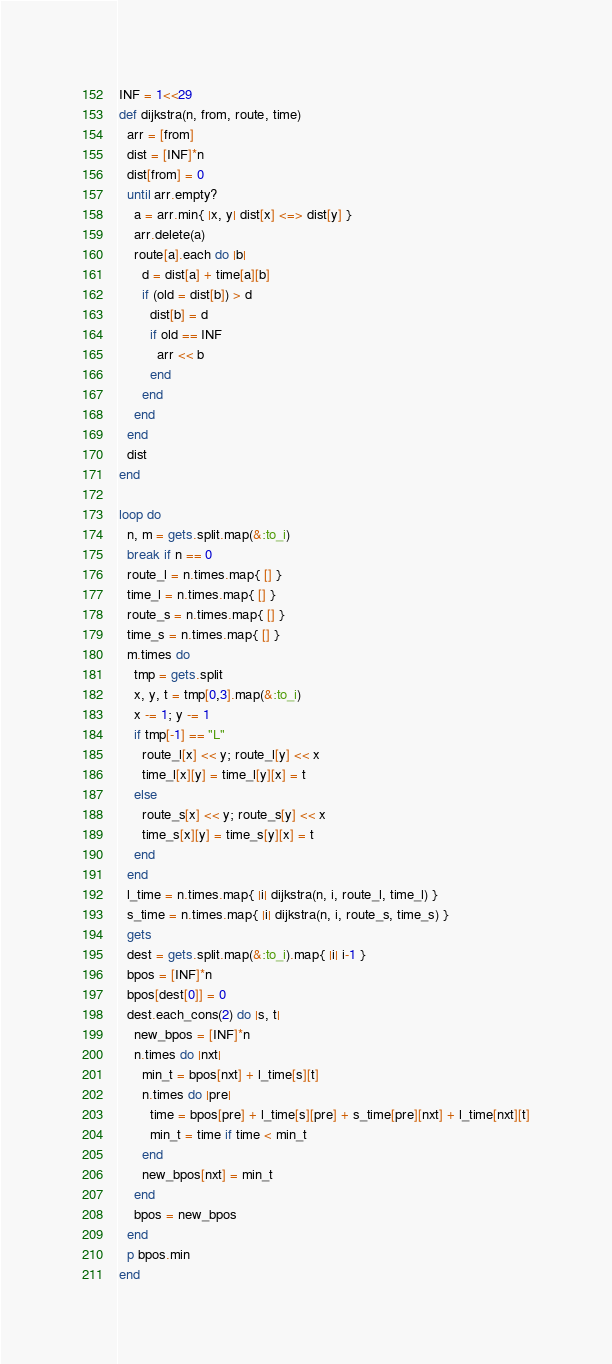<code> <loc_0><loc_0><loc_500><loc_500><_Ruby_>INF = 1<<29
def dijkstra(n, from, route, time)
  arr = [from]
  dist = [INF]*n
  dist[from] = 0
  until arr.empty?
    a = arr.min{ |x, y| dist[x] <=> dist[y] }
    arr.delete(a)
    route[a].each do |b|
      d = dist[a] + time[a][b]
      if (old = dist[b]) > d
        dist[b] = d
        if old == INF
          arr << b 
        end
      end
    end
  end
  dist
end
 
loop do
  n, m = gets.split.map(&:to_i)
  break if n == 0
  route_l = n.times.map{ [] }
  time_l = n.times.map{ [] }
  route_s = n.times.map{ [] }
  time_s = n.times.map{ [] }
  m.times do
    tmp = gets.split
    x, y, t = tmp[0,3].map(&:to_i)
    x -= 1; y -= 1
    if tmp[-1] == "L"
      route_l[x] << y; route_l[y] << x
      time_l[x][y] = time_l[y][x] = t
    else
      route_s[x] << y; route_s[y] << x
      time_s[x][y] = time_s[y][x] = t
    end
  end
  l_time = n.times.map{ |i| dijkstra(n, i, route_l, time_l) }
  s_time = n.times.map{ |i| dijkstra(n, i, route_s, time_s) }
  gets  
  dest = gets.split.map(&:to_i).map{ |i| i-1 }
  bpos = [INF]*n
  bpos[dest[0]] = 0
  dest.each_cons(2) do |s, t|
    new_bpos = [INF]*n
    n.times do |nxt|
      min_t = bpos[nxt] + l_time[s][t]
      n.times do |pre|
        time = bpos[pre] + l_time[s][pre] + s_time[pre][nxt] + l_time[nxt][t]
        min_t = time if time < min_t
      end
      new_bpos[nxt] = min_t
    end
    bpos = new_bpos
  end
  p bpos.min
end</code> 